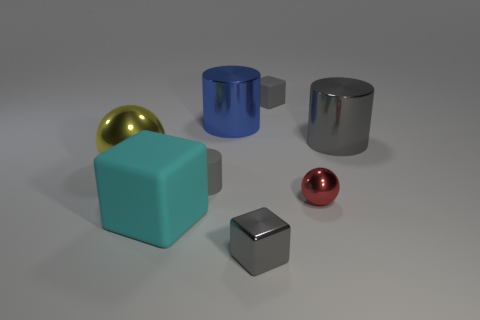Are there any small metal blocks that have the same color as the matte cylinder?
Your answer should be compact. Yes. What shape is the gray metallic thing that is the same size as the cyan matte cube?
Provide a short and direct response. Cylinder. What number of big yellow metal objects are on the left side of the gray cylinder that is behind the small gray rubber cylinder?
Give a very brief answer. 1. Does the tiny rubber cylinder have the same color as the small matte cube?
Keep it short and to the point. Yes. How many other things are there of the same material as the red sphere?
Provide a short and direct response. 4. There is a gray metallic thing right of the tiny rubber object to the right of the big blue metal cylinder; what is its shape?
Provide a short and direct response. Cylinder. There is a rubber block on the right side of the blue cylinder; how big is it?
Offer a very short reply. Small. Is the material of the large blue thing the same as the yellow object?
Keep it short and to the point. Yes. There is a small gray thing that is made of the same material as the small gray cylinder; what is its shape?
Your answer should be compact. Cube. Is there anything else that has the same color as the big cube?
Provide a succinct answer. No. 